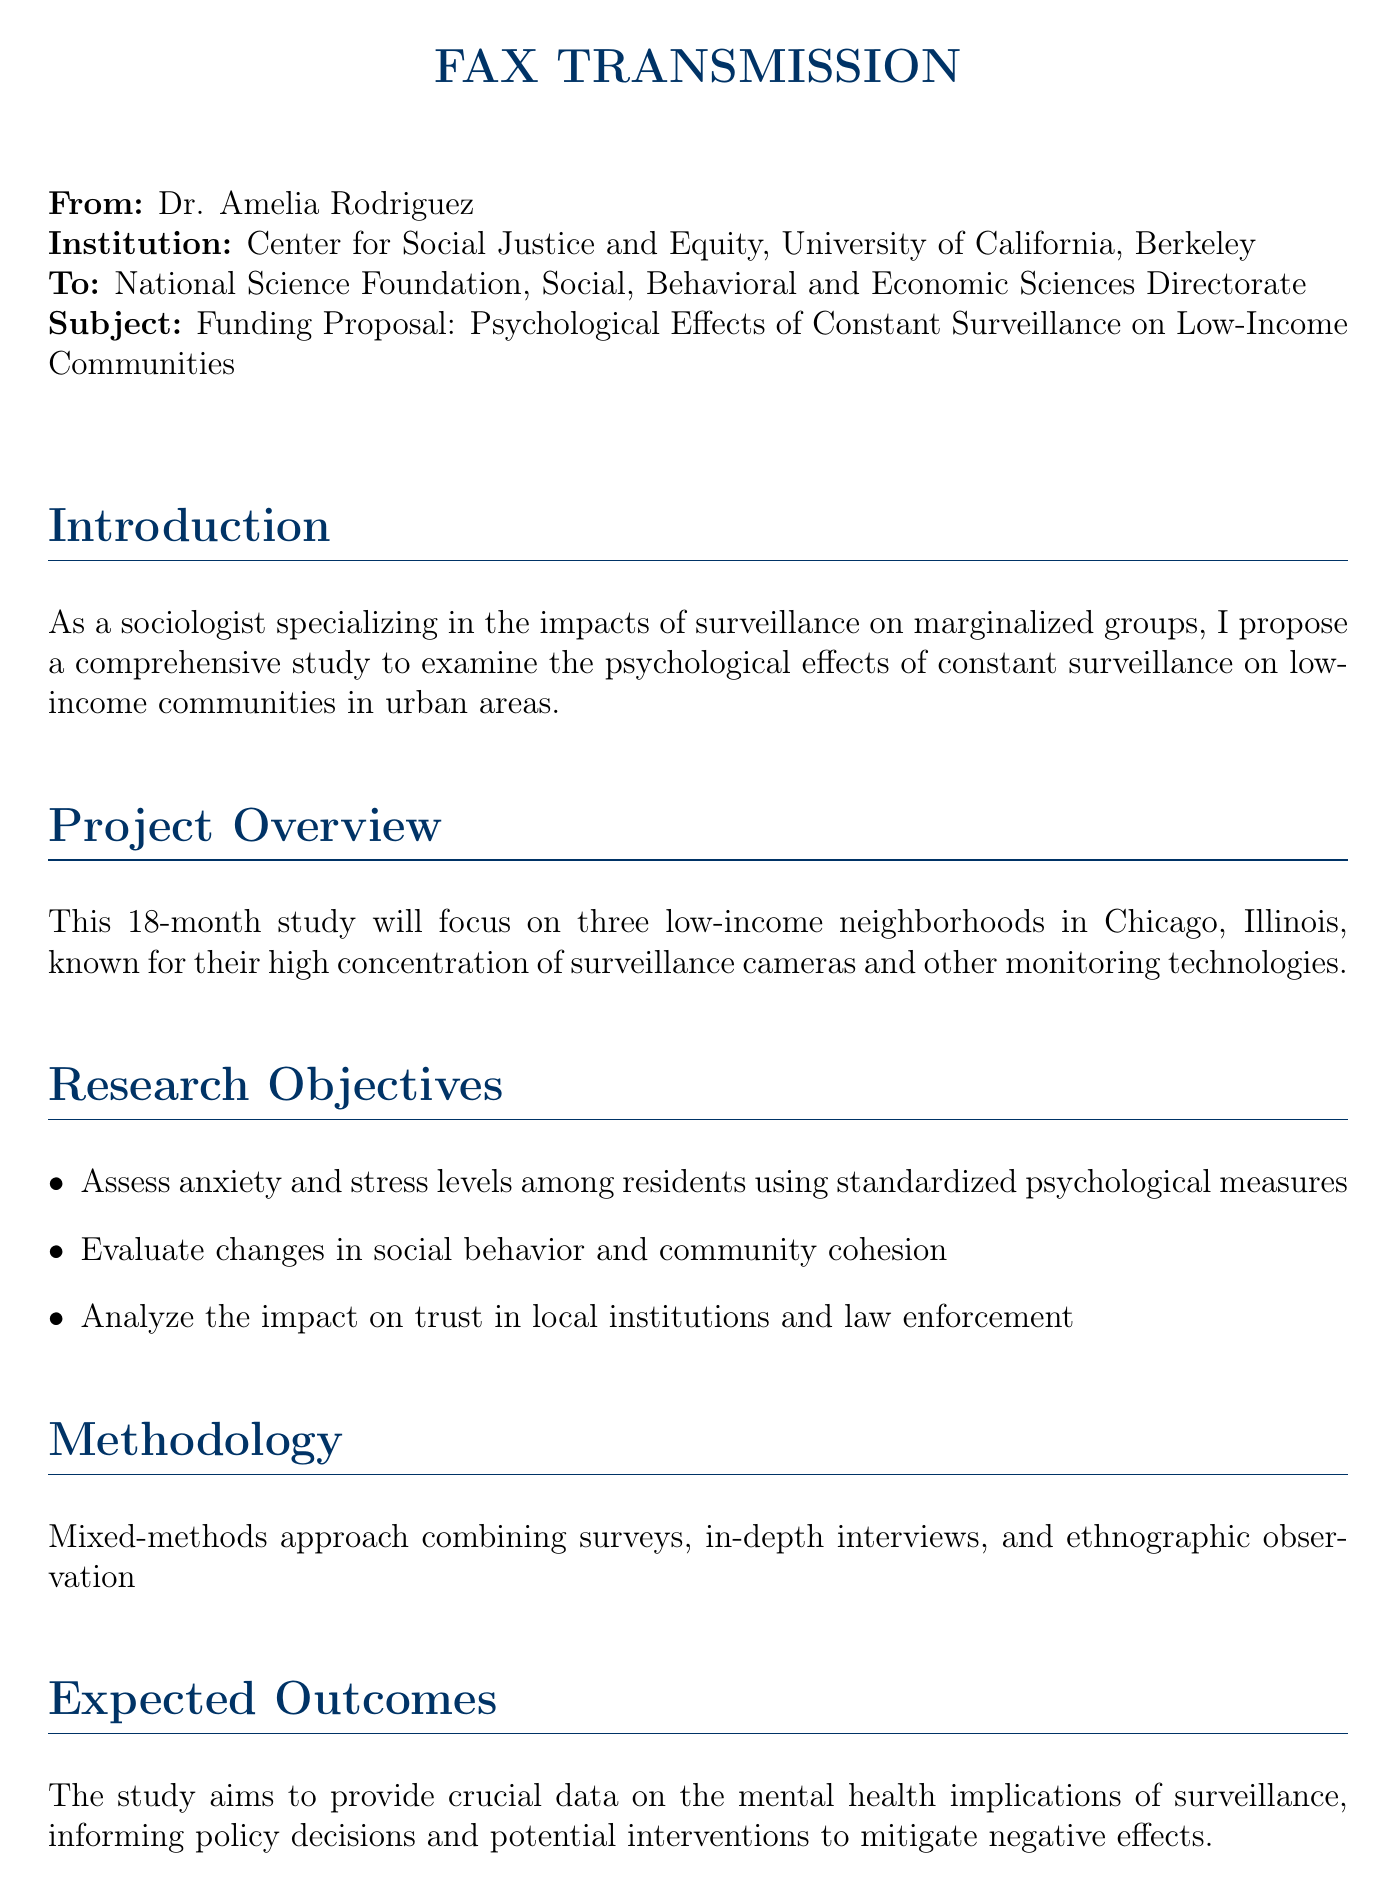what is the total requested funding? The total requested funding is found in the budget summary section where it states the overall amount needed for the study.
Answer: $275,000 who is the sender of the fax? The sender's name is listed at the top of the document under "From".
Answer: Dr. Amelia Rodriguez which institution is associated with the sender? The institution is mentioned directly after the sender's name, indicating where the sender works.
Answer: Center for Social Justice and Equity, University of California, Berkeley what is the duration of the study? The duration of the study is specified in both the project overview and timeline sections of the document.
Answer: 18 months what three neighborhoods are the focus of the study? Specific neighborhoods are mentioned that will be studied; the document specifies their focus on low-income areas in a major city.
Answer: three low-income neighborhoods in Chicago how much is allocated for participant compensation? This funding allocation is clearly stated in the budget summary section within the document.
Answer: $50,000 which method is being used for the research? The methodology for conducting the research is explicitly described in one of the sections, summarizing the approach.
Answer: Mixed-methods approach what are the primary research objectives mentioned? The objectives are listed as bullet points in the document, outlining what the study aims to accomplish.
Answer: Assess anxiety and stress levels, evaluate changes in social behavior, analyze impact on trust in institutions what is the expected end date of the study? The end date is found in the timeline section, indicating when the study is projected to be completed.
Answer: February 2025 